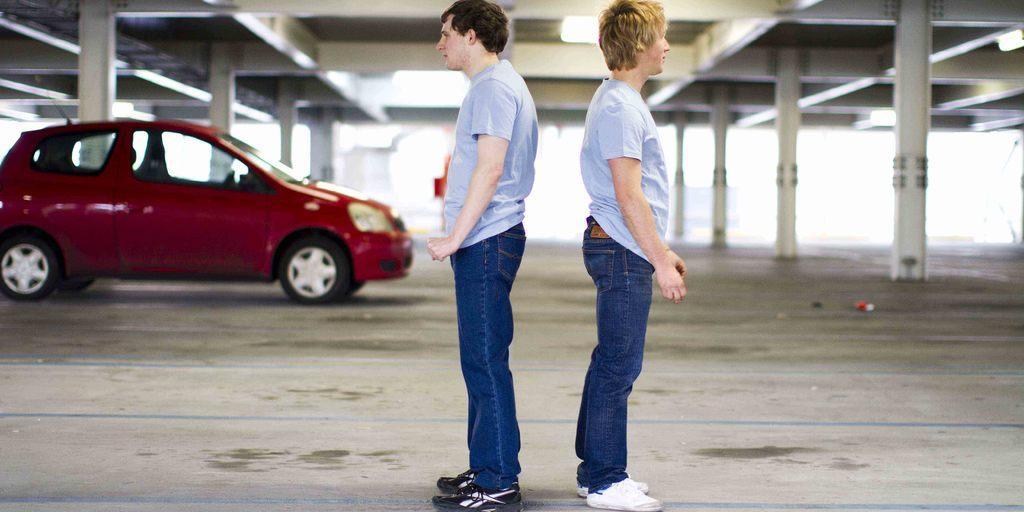How would you summarize this image in a sentence or two? In this image we can see men standing on the floor, motor vehicle, pillars and roof. 